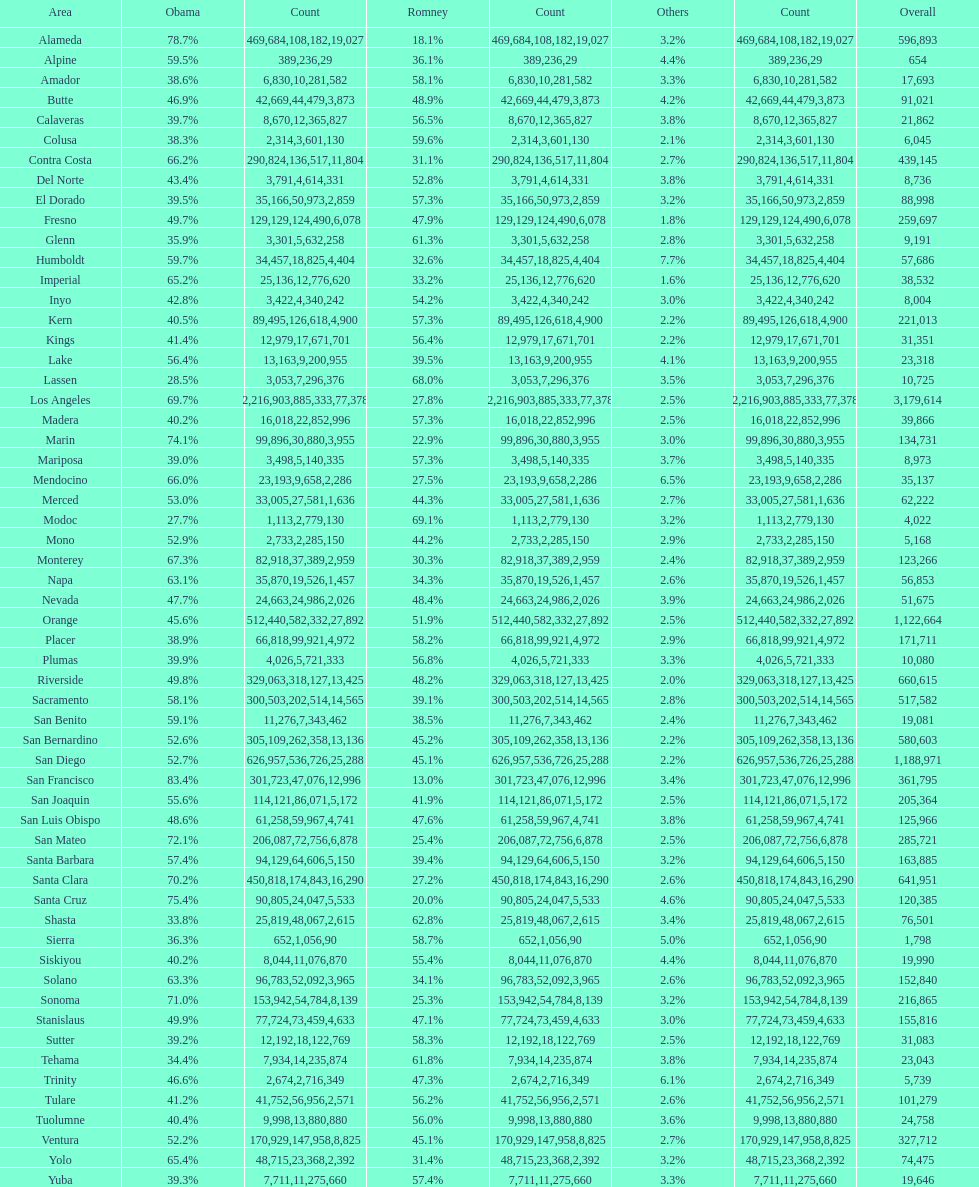What county is just before del norte on the list? Contra Costa. 